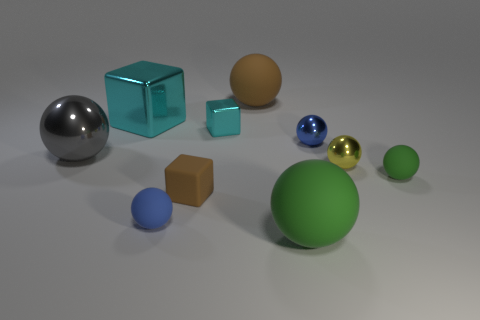What is the color of the big object that is both in front of the big brown rubber sphere and behind the blue metallic sphere?
Your answer should be compact. Cyan. Is there any other thing that has the same material as the big brown object?
Provide a short and direct response. Yes. Do the tiny brown thing and the blue thing that is on the left side of the big green rubber thing have the same material?
Your answer should be very brief. Yes. There is a metal ball that is left of the cyan metal object left of the tiny blue matte sphere; what size is it?
Give a very brief answer. Large. Is there anything else that has the same color as the matte cube?
Provide a succinct answer. Yes. Do the small blue object behind the yellow sphere and the green ball behind the brown matte cube have the same material?
Offer a terse response. No. What material is the ball that is both to the left of the tiny brown rubber cube and behind the yellow object?
Your response must be concise. Metal. Is the shape of the small green matte object the same as the brown rubber thing that is in front of the gray object?
Make the answer very short. No. What is the material of the block that is in front of the blue sphere that is right of the blue sphere that is left of the blue metal sphere?
Offer a very short reply. Rubber. How many other objects are there of the same size as the brown block?
Provide a succinct answer. 5. 